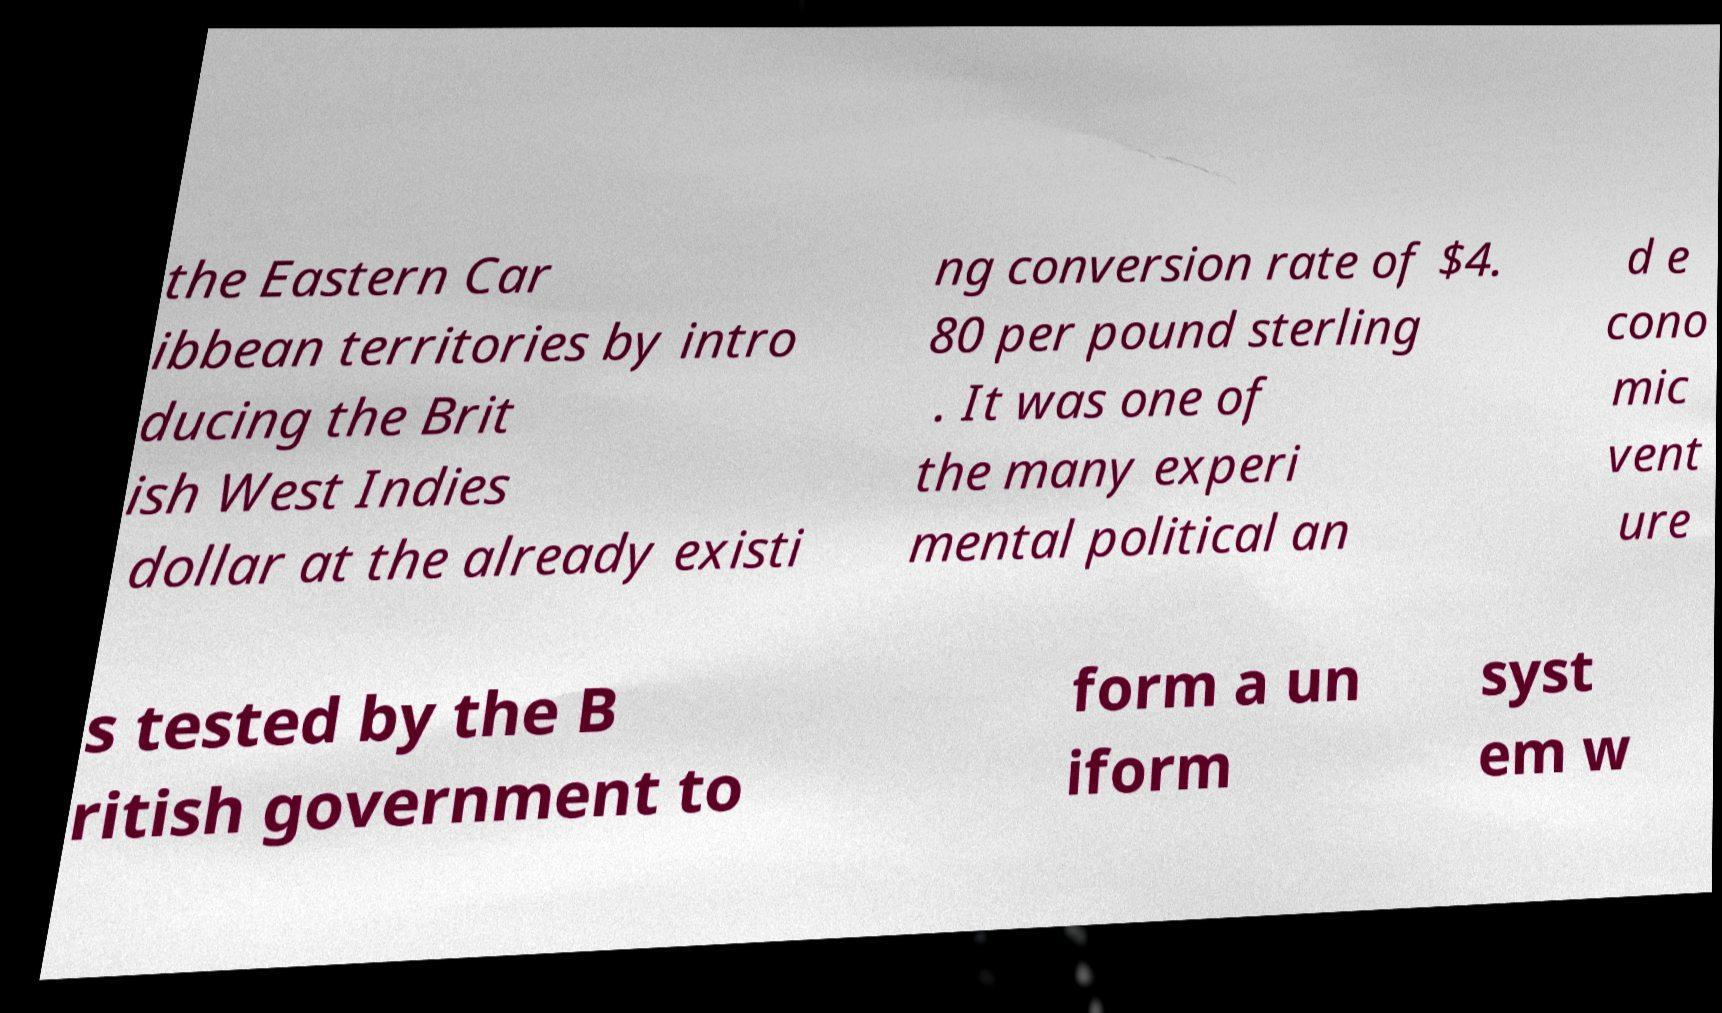Can you read and provide the text displayed in the image?This photo seems to have some interesting text. Can you extract and type it out for me? the Eastern Car ibbean territories by intro ducing the Brit ish West Indies dollar at the already existi ng conversion rate of $4. 80 per pound sterling . It was one of the many experi mental political an d e cono mic vent ure s tested by the B ritish government to form a un iform syst em w 